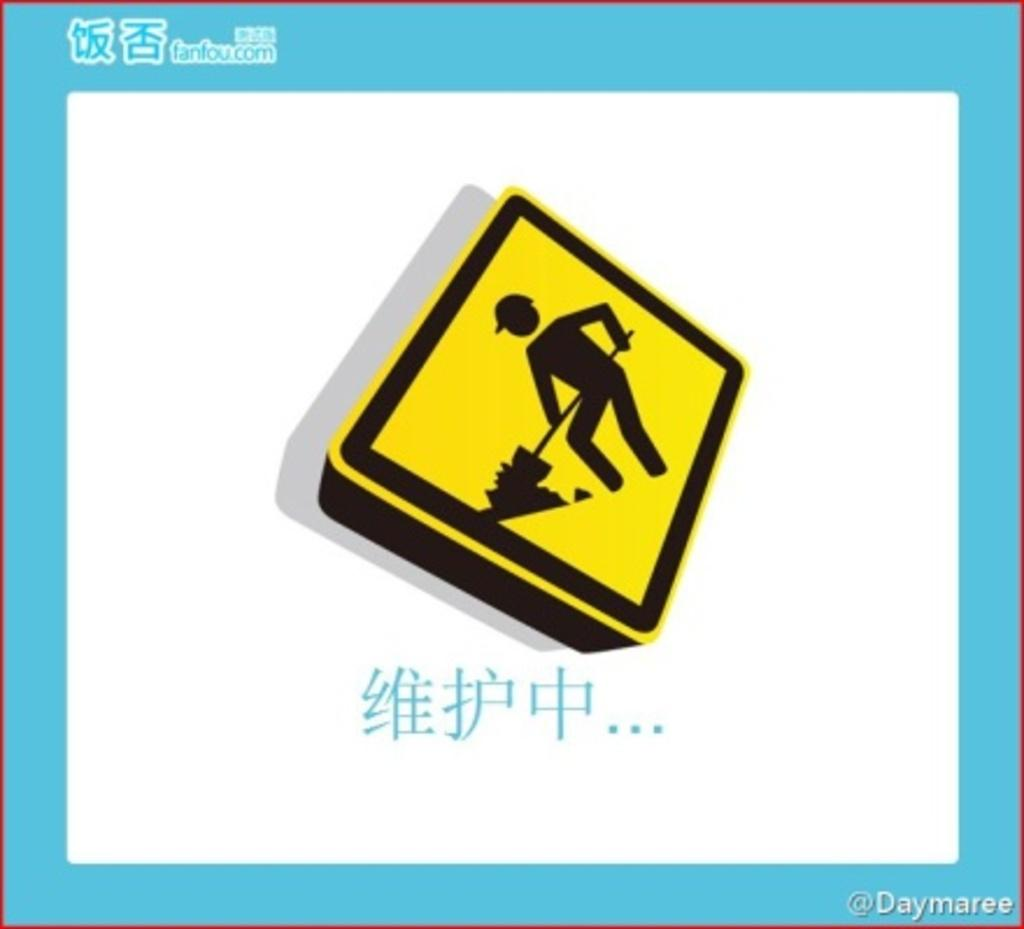<image>
Give a short and clear explanation of the subsequent image. Japanese writing next to a sign of a man digging 